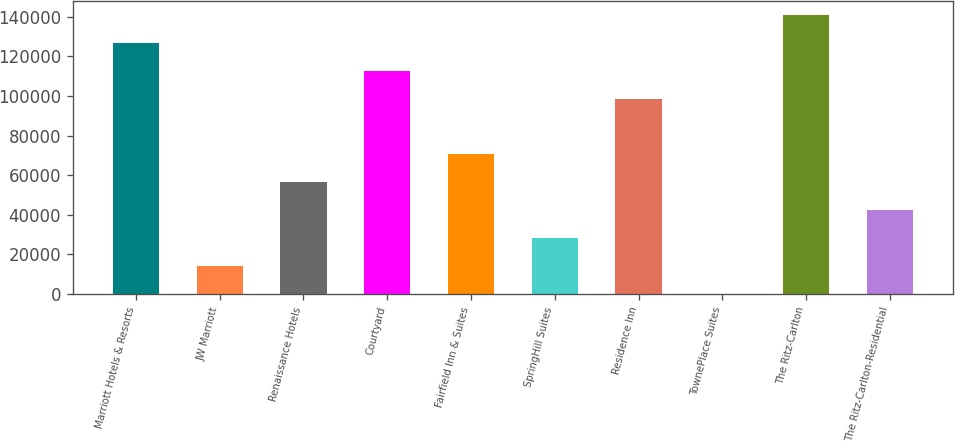Convert chart to OTSL. <chart><loc_0><loc_0><loc_500><loc_500><bar_chart><fcel>Marriott Hotels & Resorts<fcel>JW Marriott<fcel>Renaissance Hotels<fcel>Courtyard<fcel>Fairfield Inn & Suites<fcel>SpringHill Suites<fcel>Residence Inn<fcel>TownePlace Suites<fcel>The Ritz-Carlton<fcel>The Ritz-Carlton-Residential<nl><fcel>126813<fcel>14183.7<fcel>56419.8<fcel>112735<fcel>70498.5<fcel>28262.4<fcel>98655.9<fcel>105<fcel>140892<fcel>42341.1<nl></chart> 